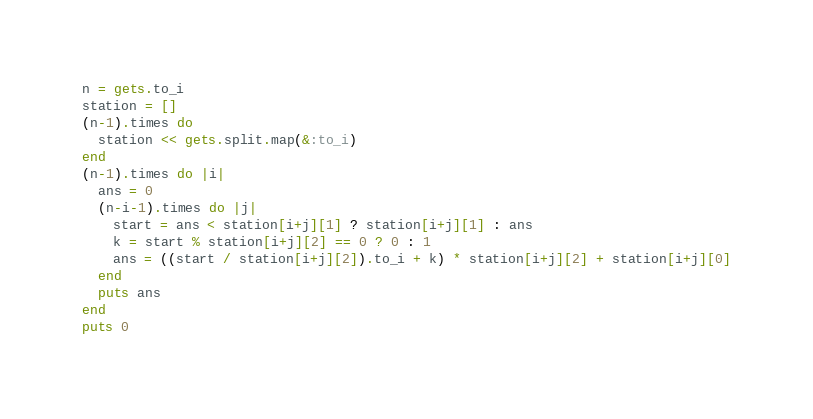<code> <loc_0><loc_0><loc_500><loc_500><_Ruby_>n = gets.to_i
station = []
(n-1).times do
  station << gets.split.map(&:to_i)
end
(n-1).times do |i|
  ans = 0
  (n-i-1).times do |j|
    start = ans < station[i+j][1] ? station[i+j][1] : ans
    k = start % station[i+j][2] == 0 ? 0 : 1
    ans = ((start / station[i+j][2]).to_i + k) * station[i+j][2] + station[i+j][0]
  end
  puts ans
end
puts 0
</code> 